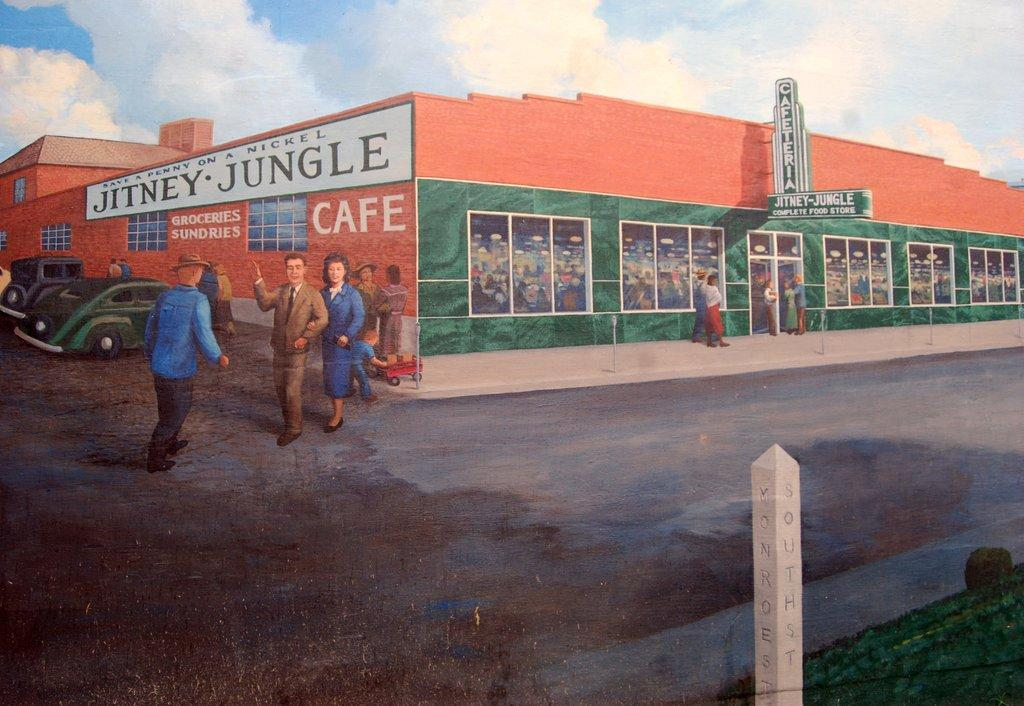What is depicted on the poster in the image? There is a poster with people in the image. What can be seen on the building in the image? There is a building with text in the image. What is visible in the sky in the image? Clouds are visible in the sky. What month is displayed on the calendar in the image? There is no calendar present in the image, so we cannot determine the month. What type of pipe is visible in the image? There is no pipe present in the image. 